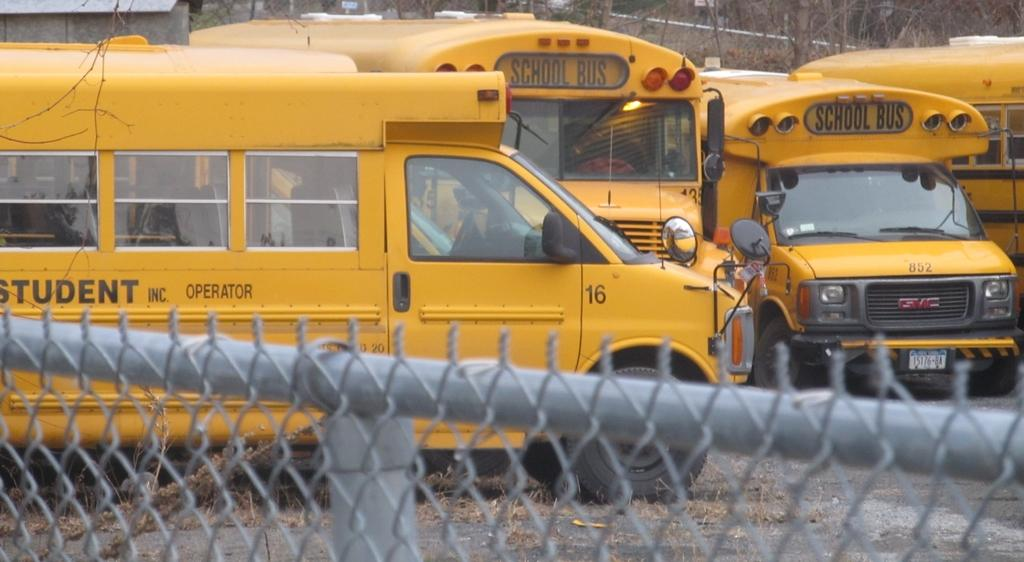What color are the vehicles in the image? The vehicles in the image are yellow. Where are the vehicles located in the image? The vehicles are on the ground. What is in front of the image? There is a fence in front of the image. What can be seen in the background of the image? There are trees in the background of the image. What type of berry is being discussed by the committee in the image? There is no committee or berry present in the image. 